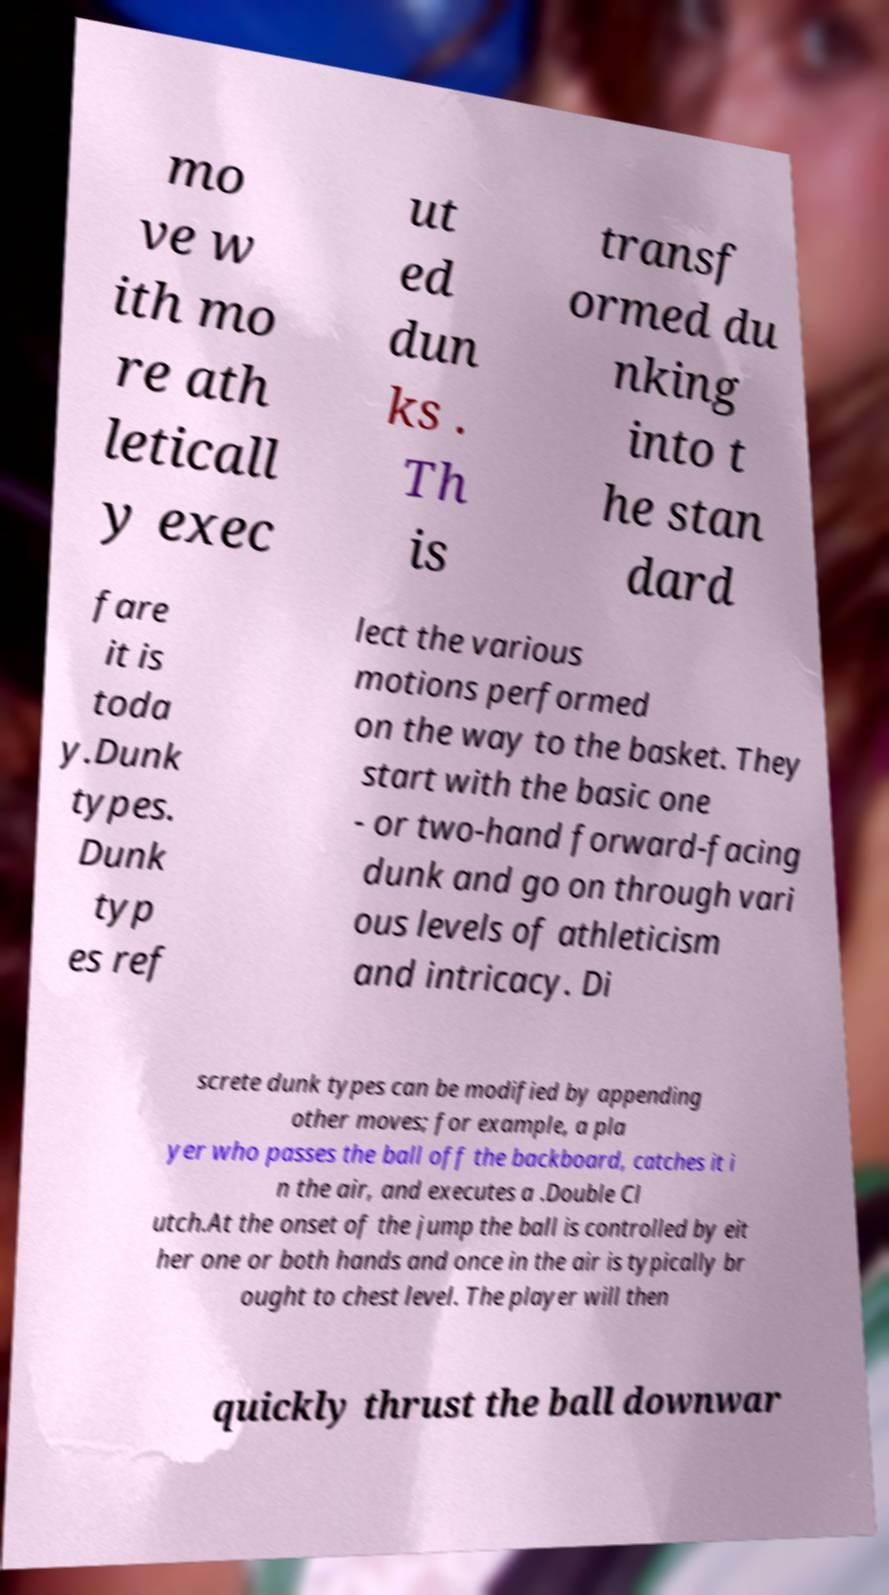Can you read and provide the text displayed in the image?This photo seems to have some interesting text. Can you extract and type it out for me? mo ve w ith mo re ath leticall y exec ut ed dun ks . Th is transf ormed du nking into t he stan dard fare it is toda y.Dunk types. Dunk typ es ref lect the various motions performed on the way to the basket. They start with the basic one - or two-hand forward-facing dunk and go on through vari ous levels of athleticism and intricacy. Di screte dunk types can be modified by appending other moves; for example, a pla yer who passes the ball off the backboard, catches it i n the air, and executes a .Double Cl utch.At the onset of the jump the ball is controlled by eit her one or both hands and once in the air is typically br ought to chest level. The player will then quickly thrust the ball downwar 